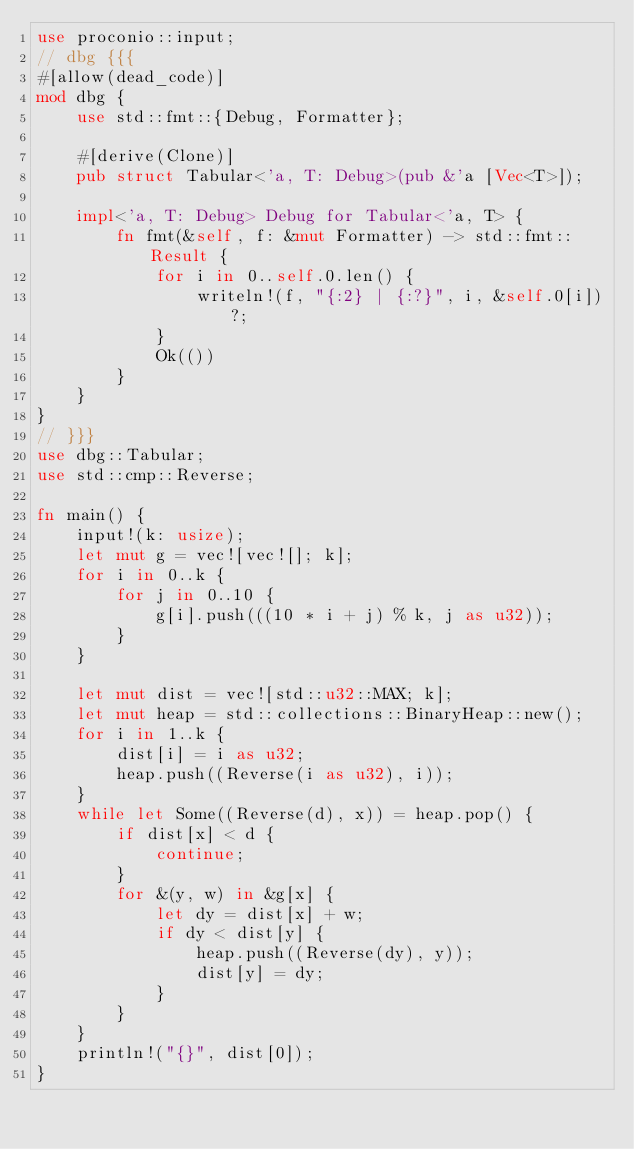Convert code to text. <code><loc_0><loc_0><loc_500><loc_500><_Rust_>use proconio::input;
// dbg {{{
#[allow(dead_code)]
mod dbg {
    use std::fmt::{Debug, Formatter};

    #[derive(Clone)]
    pub struct Tabular<'a, T: Debug>(pub &'a [Vec<T>]);

    impl<'a, T: Debug> Debug for Tabular<'a, T> {
        fn fmt(&self, f: &mut Formatter) -> std::fmt::Result {
            for i in 0..self.0.len() {
                writeln!(f, "{:2} | {:?}", i, &self.0[i])?;
            }
            Ok(())
        }
    }
}
// }}}
use dbg::Tabular;
use std::cmp::Reverse;

fn main() {
    input!(k: usize);
    let mut g = vec![vec![]; k];
    for i in 0..k {
        for j in 0..10 {
            g[i].push(((10 * i + j) % k, j as u32));
        }
    }

    let mut dist = vec![std::u32::MAX; k];
    let mut heap = std::collections::BinaryHeap::new();
    for i in 1..k {
        dist[i] = i as u32;
        heap.push((Reverse(i as u32), i));
    }
    while let Some((Reverse(d), x)) = heap.pop() {
        if dist[x] < d {
            continue;
        }
        for &(y, w) in &g[x] {
            let dy = dist[x] + w;
            if dy < dist[y] {
                heap.push((Reverse(dy), y));
                dist[y] = dy;
            }
        }
    }
    println!("{}", dist[0]);
}
</code> 